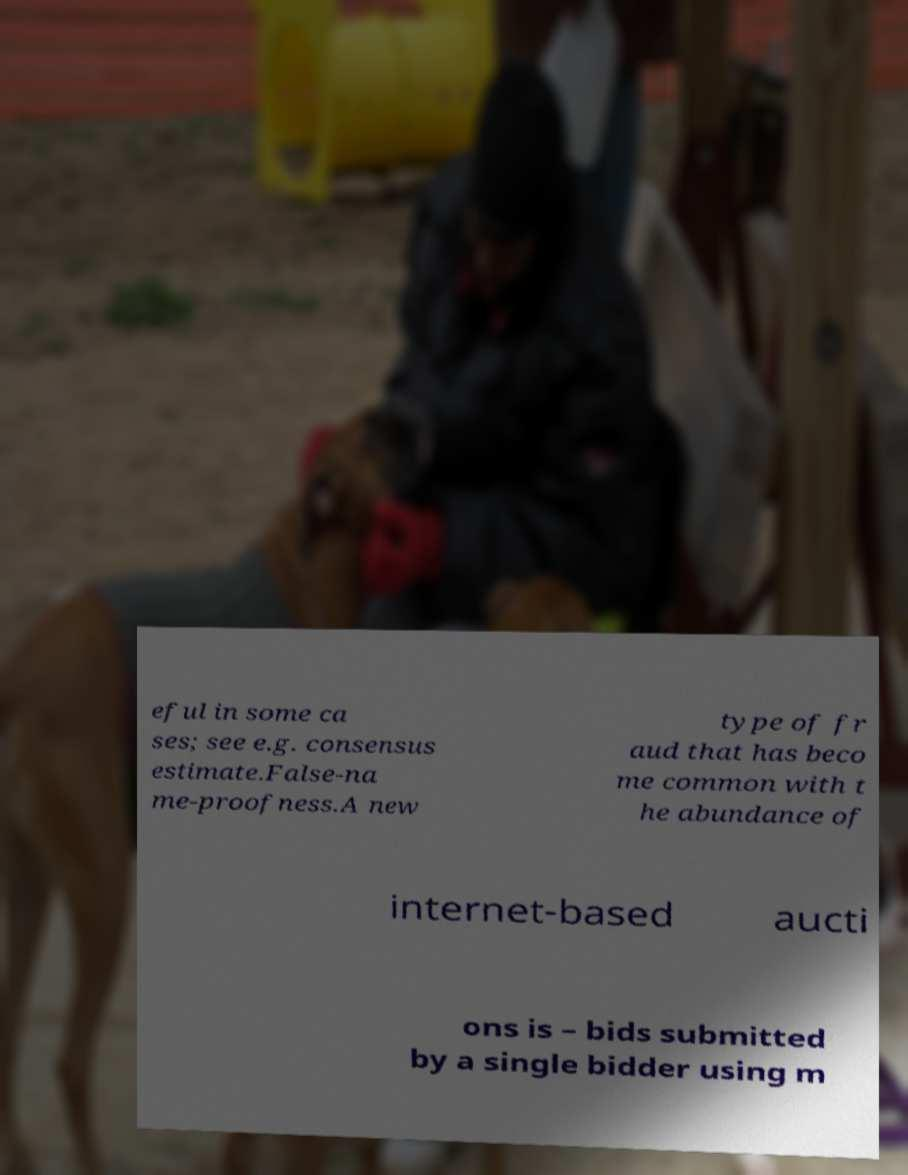What messages or text are displayed in this image? I need them in a readable, typed format. eful in some ca ses; see e.g. consensus estimate.False-na me-proofness.A new type of fr aud that has beco me common with t he abundance of internet-based aucti ons is – bids submitted by a single bidder using m 